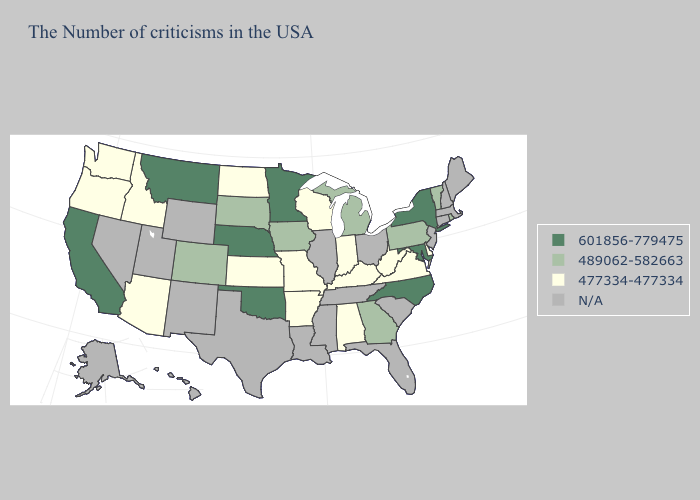What is the value of Connecticut?
Answer briefly. N/A. What is the highest value in the Northeast ?
Keep it brief. 601856-779475. Name the states that have a value in the range 601856-779475?
Quick response, please. New York, Maryland, North Carolina, Minnesota, Nebraska, Oklahoma, Montana, California. What is the highest value in the USA?
Keep it brief. 601856-779475. Which states have the lowest value in the MidWest?
Concise answer only. Indiana, Wisconsin, Missouri, Kansas, North Dakota. What is the value of Connecticut?
Keep it brief. N/A. Is the legend a continuous bar?
Short answer required. No. Among the states that border Oregon , does California have the lowest value?
Answer briefly. No. Among the states that border South Carolina , does North Carolina have the highest value?
Give a very brief answer. Yes. What is the value of New Hampshire?
Write a very short answer. N/A. Which states have the lowest value in the MidWest?
Write a very short answer. Indiana, Wisconsin, Missouri, Kansas, North Dakota. What is the value of Ohio?
Be succinct. N/A. What is the value of Vermont?
Answer briefly. 489062-582663. What is the value of Kentucky?
Be succinct. 477334-477334. What is the value of Illinois?
Give a very brief answer. N/A. 